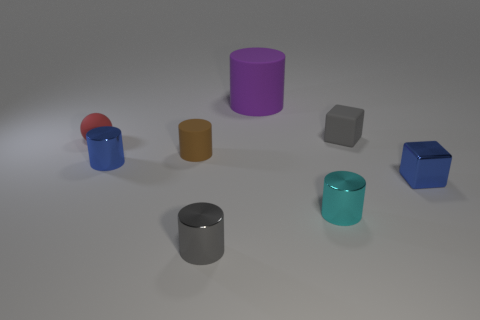Is there anything else of the same color as the matte ball?
Your response must be concise. No. Are the purple thing and the small thing behind the small sphere made of the same material?
Provide a succinct answer. Yes. What material is the brown thing that is the same shape as the purple thing?
Ensure brevity in your answer.  Rubber. Are the small blue object right of the gray metallic object and the tiny sphere that is on the left side of the tiny rubber block made of the same material?
Keep it short and to the point. No. The small shiny cylinder that is behind the small blue object on the right side of the cylinder on the right side of the large object is what color?
Offer a very short reply. Blue. How many other objects are the same shape as the red thing?
Your answer should be very brief. 0. How many things are either yellow matte cylinders or metallic things on the left side of the small gray cube?
Offer a terse response. 3. Is there a cube of the same size as the rubber ball?
Provide a succinct answer. Yes. Is the material of the tiny brown thing the same as the big purple object?
Offer a very short reply. Yes. How many objects are gray cubes or blue metallic objects?
Ensure brevity in your answer.  3. 